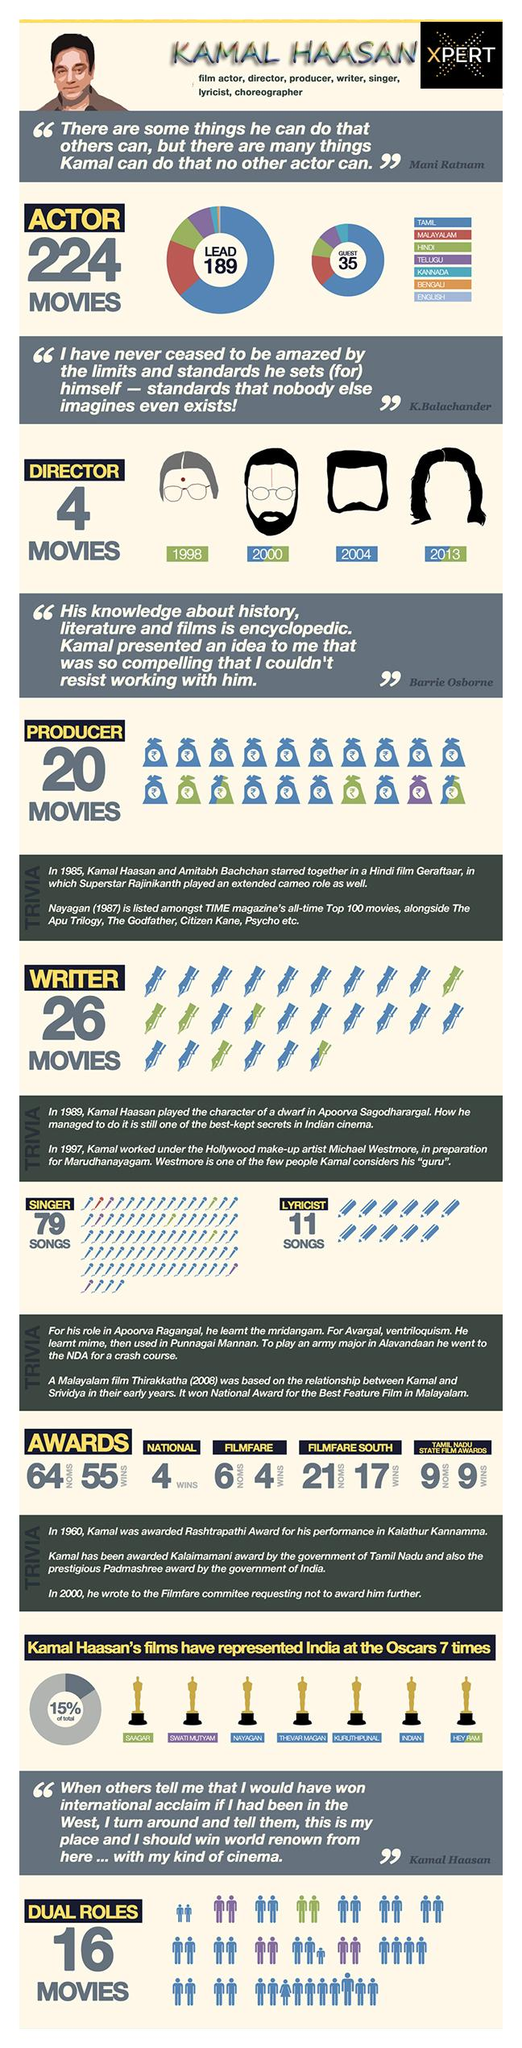Mention a couple of crucial points in this snapshot. He has played dual roles in three Telugu movies. The person won the Tamil Nadu State Film Award 9 times. He wrote the lyrics for his songs in the Tamil language. The individual in question has received four Filmfare awards. The movie directed by Kamal Haasan in 1998, which was in the language of Hindi, was a successful and critically acclaimed film. 